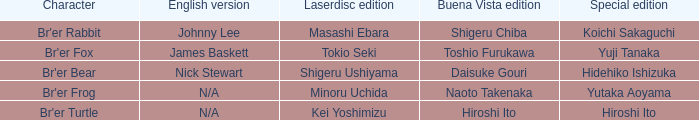Which role is associated with koichi sakaguchi in the special edition? Br'er Rabbit. Would you mind parsing the complete table? {'header': ['Character', 'English version', 'Laserdisc edition', 'Buena Vista edition', 'Special edition'], 'rows': [["Br'er Rabbit", 'Johnny Lee', 'Masashi Ebara', 'Shigeru Chiba', 'Koichi Sakaguchi'], ["Br'er Fox", 'James Baskett', 'Tokio Seki', 'Toshio Furukawa', 'Yuji Tanaka'], ["Br'er Bear", 'Nick Stewart', 'Shigeru Ushiyama', 'Daisuke Gouri', 'Hidehiko Ishizuka'], ["Br'er Frog", 'N/A', 'Minoru Uchida', 'Naoto Takenaka', 'Yutaka Aoyama'], ["Br'er Turtle", 'N/A', 'Kei Yoshimizu', 'Hiroshi Ito', 'Hiroshi Ito']]} 